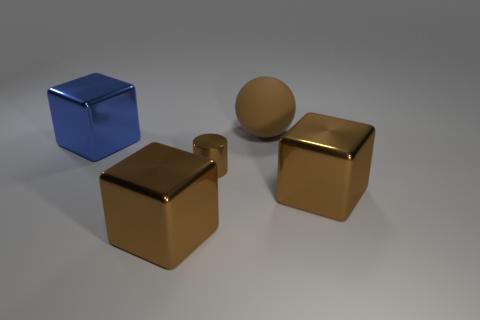Add 5 large metallic things. How many objects exist? 10 Subtract all cubes. How many objects are left? 2 Subtract 0 purple blocks. How many objects are left? 5 Subtract all big matte balls. Subtract all brown metal cylinders. How many objects are left? 3 Add 3 big brown spheres. How many big brown spheres are left? 4 Add 3 blue things. How many blue things exist? 4 